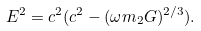Convert formula to latex. <formula><loc_0><loc_0><loc_500><loc_500>E ^ { 2 } = c ^ { 2 } ( c ^ { 2 } - ( \omega m _ { 2 } G ) ^ { 2 / 3 } ) .</formula> 